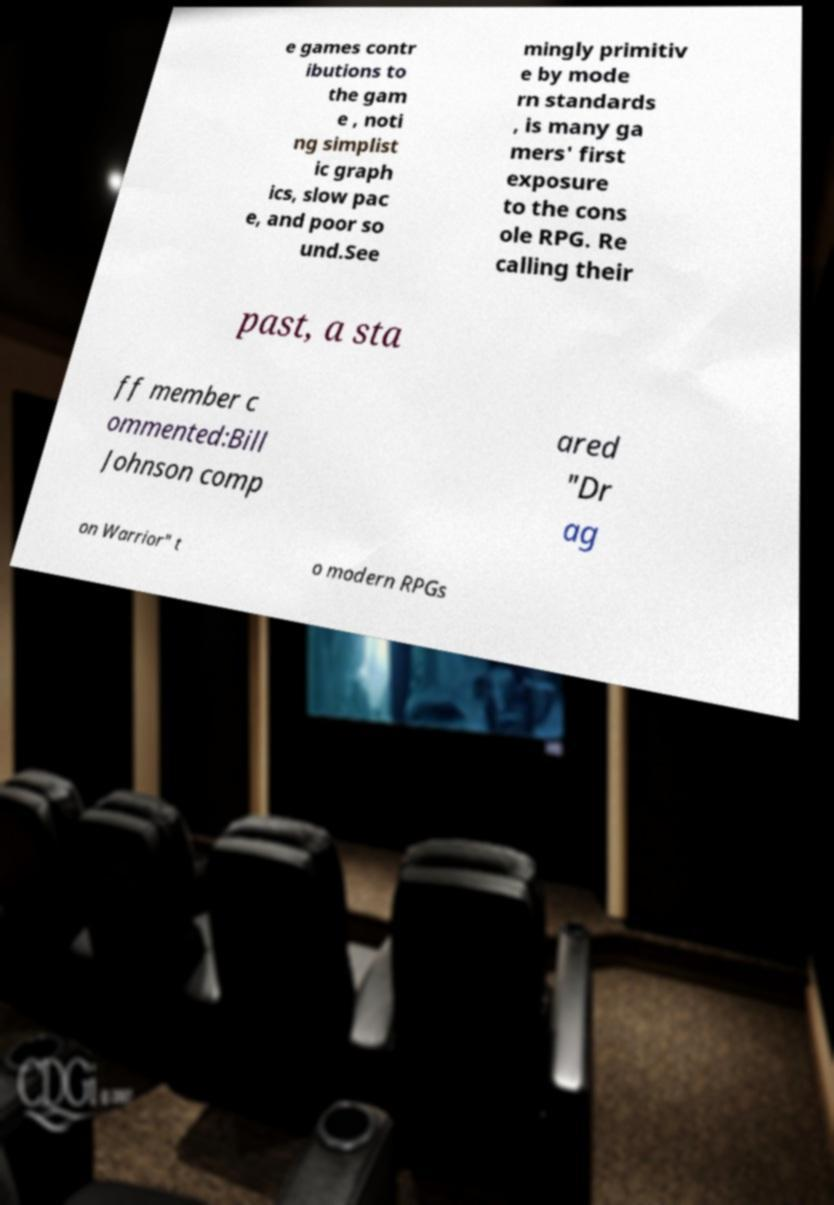I need the written content from this picture converted into text. Can you do that? e games contr ibutions to the gam e , noti ng simplist ic graph ics, slow pac e, and poor so und.See mingly primitiv e by mode rn standards , is many ga mers' first exposure to the cons ole RPG. Re calling their past, a sta ff member c ommented:Bill Johnson comp ared "Dr ag on Warrior" t o modern RPGs 